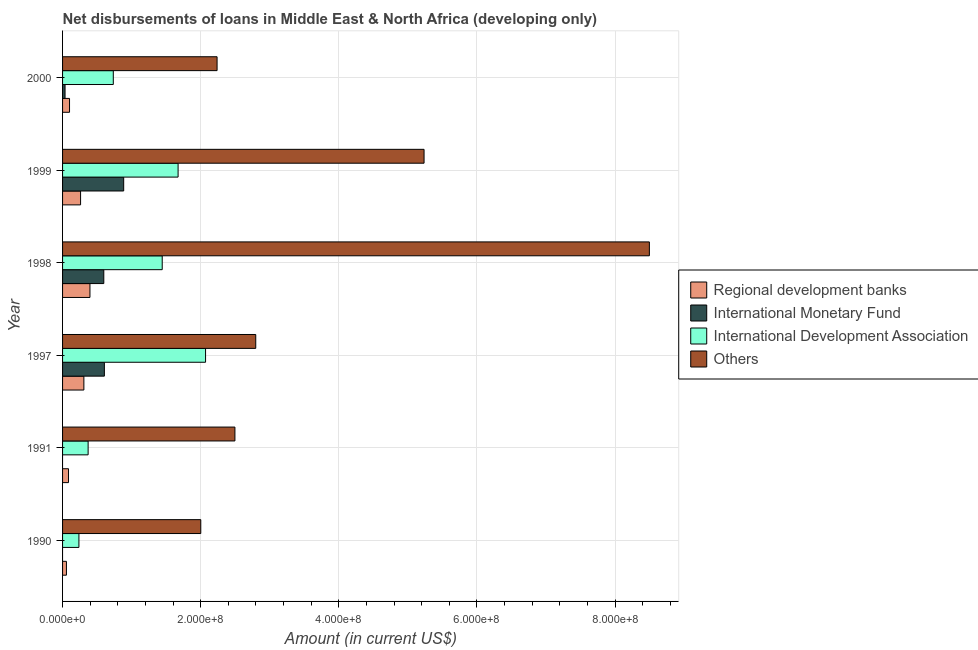How many groups of bars are there?
Give a very brief answer. 6. What is the amount of loan disimbursed by international development association in 1990?
Keep it short and to the point. 2.37e+07. Across all years, what is the maximum amount of loan disimbursed by regional development banks?
Offer a terse response. 3.97e+07. Across all years, what is the minimum amount of loan disimbursed by international monetary fund?
Your response must be concise. 0. What is the total amount of loan disimbursed by international development association in the graph?
Provide a short and direct response. 6.53e+08. What is the difference between the amount of loan disimbursed by international monetary fund in 1998 and that in 2000?
Your answer should be compact. 5.61e+07. What is the difference between the amount of loan disimbursed by regional development banks in 2000 and the amount of loan disimbursed by international development association in 1991?
Give a very brief answer. -2.69e+07. What is the average amount of loan disimbursed by regional development banks per year?
Offer a terse response. 2.01e+07. In the year 1990, what is the difference between the amount of loan disimbursed by international development association and amount of loan disimbursed by regional development banks?
Your answer should be very brief. 1.81e+07. Is the amount of loan disimbursed by international monetary fund in 1999 less than that in 2000?
Ensure brevity in your answer.  No. What is the difference between the highest and the second highest amount of loan disimbursed by international development association?
Your answer should be very brief. 3.98e+07. What is the difference between the highest and the lowest amount of loan disimbursed by regional development banks?
Your answer should be very brief. 3.40e+07. Is it the case that in every year, the sum of the amount of loan disimbursed by international monetary fund and amount of loan disimbursed by international development association is greater than the sum of amount of loan disimbursed by other organisations and amount of loan disimbursed by regional development banks?
Your answer should be compact. No. How many bars are there?
Your answer should be very brief. 22. Are all the bars in the graph horizontal?
Your answer should be compact. Yes. How many years are there in the graph?
Your response must be concise. 6. Does the graph contain any zero values?
Offer a very short reply. Yes. What is the title of the graph?
Your response must be concise. Net disbursements of loans in Middle East & North Africa (developing only). Does "Luxembourg" appear as one of the legend labels in the graph?
Your response must be concise. No. What is the label or title of the Y-axis?
Offer a very short reply. Year. What is the Amount (in current US$) in Regional development banks in 1990?
Keep it short and to the point. 5.62e+06. What is the Amount (in current US$) in International Development Association in 1990?
Give a very brief answer. 2.37e+07. What is the Amount (in current US$) in Others in 1990?
Ensure brevity in your answer.  2.00e+08. What is the Amount (in current US$) in Regional development banks in 1991?
Provide a succinct answer. 8.61e+06. What is the Amount (in current US$) of International Development Association in 1991?
Your response must be concise. 3.70e+07. What is the Amount (in current US$) in Others in 1991?
Keep it short and to the point. 2.50e+08. What is the Amount (in current US$) of Regional development banks in 1997?
Give a very brief answer. 3.09e+07. What is the Amount (in current US$) of International Monetary Fund in 1997?
Offer a very short reply. 6.05e+07. What is the Amount (in current US$) of International Development Association in 1997?
Make the answer very short. 2.07e+08. What is the Amount (in current US$) in Others in 1997?
Ensure brevity in your answer.  2.80e+08. What is the Amount (in current US$) in Regional development banks in 1998?
Make the answer very short. 3.97e+07. What is the Amount (in current US$) of International Monetary Fund in 1998?
Provide a short and direct response. 5.97e+07. What is the Amount (in current US$) of International Development Association in 1998?
Make the answer very short. 1.44e+08. What is the Amount (in current US$) of Others in 1998?
Ensure brevity in your answer.  8.50e+08. What is the Amount (in current US$) of Regional development banks in 1999?
Keep it short and to the point. 2.61e+07. What is the Amount (in current US$) of International Monetary Fund in 1999?
Your response must be concise. 8.85e+07. What is the Amount (in current US$) of International Development Association in 1999?
Provide a short and direct response. 1.67e+08. What is the Amount (in current US$) of Others in 1999?
Provide a short and direct response. 5.23e+08. What is the Amount (in current US$) of Regional development banks in 2000?
Offer a terse response. 1.01e+07. What is the Amount (in current US$) in International Monetary Fund in 2000?
Offer a terse response. 3.60e+06. What is the Amount (in current US$) in International Development Association in 2000?
Your answer should be compact. 7.35e+07. What is the Amount (in current US$) in Others in 2000?
Offer a terse response. 2.24e+08. Across all years, what is the maximum Amount (in current US$) in Regional development banks?
Keep it short and to the point. 3.97e+07. Across all years, what is the maximum Amount (in current US$) of International Monetary Fund?
Provide a short and direct response. 8.85e+07. Across all years, what is the maximum Amount (in current US$) in International Development Association?
Provide a short and direct response. 2.07e+08. Across all years, what is the maximum Amount (in current US$) in Others?
Offer a terse response. 8.50e+08. Across all years, what is the minimum Amount (in current US$) in Regional development banks?
Ensure brevity in your answer.  5.62e+06. Across all years, what is the minimum Amount (in current US$) in International Monetary Fund?
Offer a terse response. 0. Across all years, what is the minimum Amount (in current US$) of International Development Association?
Offer a very short reply. 2.37e+07. Across all years, what is the minimum Amount (in current US$) of Others?
Keep it short and to the point. 2.00e+08. What is the total Amount (in current US$) in Regional development banks in the graph?
Provide a short and direct response. 1.21e+08. What is the total Amount (in current US$) of International Monetary Fund in the graph?
Your answer should be compact. 2.12e+08. What is the total Amount (in current US$) in International Development Association in the graph?
Your response must be concise. 6.53e+08. What is the total Amount (in current US$) of Others in the graph?
Your response must be concise. 2.33e+09. What is the difference between the Amount (in current US$) in Regional development banks in 1990 and that in 1991?
Offer a very short reply. -2.99e+06. What is the difference between the Amount (in current US$) in International Development Association in 1990 and that in 1991?
Provide a short and direct response. -1.33e+07. What is the difference between the Amount (in current US$) in Others in 1990 and that in 1991?
Your response must be concise. -4.94e+07. What is the difference between the Amount (in current US$) in Regional development banks in 1990 and that in 1997?
Your answer should be compact. -2.52e+07. What is the difference between the Amount (in current US$) in International Development Association in 1990 and that in 1997?
Offer a very short reply. -1.83e+08. What is the difference between the Amount (in current US$) in Others in 1990 and that in 1997?
Keep it short and to the point. -7.96e+07. What is the difference between the Amount (in current US$) of Regional development banks in 1990 and that in 1998?
Ensure brevity in your answer.  -3.40e+07. What is the difference between the Amount (in current US$) of International Development Association in 1990 and that in 1998?
Your response must be concise. -1.21e+08. What is the difference between the Amount (in current US$) in Others in 1990 and that in 1998?
Keep it short and to the point. -6.50e+08. What is the difference between the Amount (in current US$) in Regional development banks in 1990 and that in 1999?
Give a very brief answer. -2.05e+07. What is the difference between the Amount (in current US$) in International Development Association in 1990 and that in 1999?
Give a very brief answer. -1.44e+08. What is the difference between the Amount (in current US$) of Others in 1990 and that in 1999?
Give a very brief answer. -3.23e+08. What is the difference between the Amount (in current US$) of Regional development banks in 1990 and that in 2000?
Your answer should be very brief. -4.46e+06. What is the difference between the Amount (in current US$) in International Development Association in 1990 and that in 2000?
Provide a short and direct response. -4.98e+07. What is the difference between the Amount (in current US$) in Others in 1990 and that in 2000?
Your answer should be compact. -2.36e+07. What is the difference between the Amount (in current US$) of Regional development banks in 1991 and that in 1997?
Make the answer very short. -2.22e+07. What is the difference between the Amount (in current US$) of International Development Association in 1991 and that in 1997?
Provide a succinct answer. -1.70e+08. What is the difference between the Amount (in current US$) of Others in 1991 and that in 1997?
Keep it short and to the point. -3.02e+07. What is the difference between the Amount (in current US$) in Regional development banks in 1991 and that in 1998?
Your answer should be compact. -3.10e+07. What is the difference between the Amount (in current US$) of International Development Association in 1991 and that in 1998?
Your response must be concise. -1.07e+08. What is the difference between the Amount (in current US$) of Others in 1991 and that in 1998?
Keep it short and to the point. -6.00e+08. What is the difference between the Amount (in current US$) of Regional development banks in 1991 and that in 1999?
Your answer should be very brief. -1.75e+07. What is the difference between the Amount (in current US$) in International Development Association in 1991 and that in 1999?
Provide a short and direct response. -1.30e+08. What is the difference between the Amount (in current US$) of Others in 1991 and that in 1999?
Provide a short and direct response. -2.74e+08. What is the difference between the Amount (in current US$) in Regional development banks in 1991 and that in 2000?
Give a very brief answer. -1.47e+06. What is the difference between the Amount (in current US$) in International Development Association in 1991 and that in 2000?
Make the answer very short. -3.65e+07. What is the difference between the Amount (in current US$) in Others in 1991 and that in 2000?
Offer a very short reply. 2.58e+07. What is the difference between the Amount (in current US$) in Regional development banks in 1997 and that in 1998?
Your answer should be compact. -8.80e+06. What is the difference between the Amount (in current US$) in International Monetary Fund in 1997 and that in 1998?
Your response must be concise. 8.50e+05. What is the difference between the Amount (in current US$) of International Development Association in 1997 and that in 1998?
Your response must be concise. 6.28e+07. What is the difference between the Amount (in current US$) of Others in 1997 and that in 1998?
Your answer should be very brief. -5.70e+08. What is the difference between the Amount (in current US$) in Regional development banks in 1997 and that in 1999?
Provide a short and direct response. 4.76e+06. What is the difference between the Amount (in current US$) of International Monetary Fund in 1997 and that in 1999?
Ensure brevity in your answer.  -2.80e+07. What is the difference between the Amount (in current US$) of International Development Association in 1997 and that in 1999?
Ensure brevity in your answer.  3.98e+07. What is the difference between the Amount (in current US$) of Others in 1997 and that in 1999?
Ensure brevity in your answer.  -2.44e+08. What is the difference between the Amount (in current US$) in Regional development banks in 1997 and that in 2000?
Offer a terse response. 2.08e+07. What is the difference between the Amount (in current US$) of International Monetary Fund in 1997 and that in 2000?
Offer a very short reply. 5.70e+07. What is the difference between the Amount (in current US$) of International Development Association in 1997 and that in 2000?
Ensure brevity in your answer.  1.34e+08. What is the difference between the Amount (in current US$) in Others in 1997 and that in 2000?
Keep it short and to the point. 5.60e+07. What is the difference between the Amount (in current US$) of Regional development banks in 1998 and that in 1999?
Offer a very short reply. 1.36e+07. What is the difference between the Amount (in current US$) in International Monetary Fund in 1998 and that in 1999?
Your response must be concise. -2.88e+07. What is the difference between the Amount (in current US$) in International Development Association in 1998 and that in 1999?
Provide a short and direct response. -2.30e+07. What is the difference between the Amount (in current US$) in Others in 1998 and that in 1999?
Offer a very short reply. 3.26e+08. What is the difference between the Amount (in current US$) of Regional development banks in 1998 and that in 2000?
Provide a short and direct response. 2.96e+07. What is the difference between the Amount (in current US$) in International Monetary Fund in 1998 and that in 2000?
Provide a short and direct response. 5.61e+07. What is the difference between the Amount (in current US$) in International Development Association in 1998 and that in 2000?
Keep it short and to the point. 7.08e+07. What is the difference between the Amount (in current US$) of Others in 1998 and that in 2000?
Keep it short and to the point. 6.26e+08. What is the difference between the Amount (in current US$) in Regional development banks in 1999 and that in 2000?
Make the answer very short. 1.60e+07. What is the difference between the Amount (in current US$) in International Monetary Fund in 1999 and that in 2000?
Your answer should be very brief. 8.49e+07. What is the difference between the Amount (in current US$) of International Development Association in 1999 and that in 2000?
Make the answer very short. 9.38e+07. What is the difference between the Amount (in current US$) of Others in 1999 and that in 2000?
Ensure brevity in your answer.  3.00e+08. What is the difference between the Amount (in current US$) of Regional development banks in 1990 and the Amount (in current US$) of International Development Association in 1991?
Ensure brevity in your answer.  -3.14e+07. What is the difference between the Amount (in current US$) of Regional development banks in 1990 and the Amount (in current US$) of Others in 1991?
Give a very brief answer. -2.44e+08. What is the difference between the Amount (in current US$) in International Development Association in 1990 and the Amount (in current US$) in Others in 1991?
Offer a very short reply. -2.26e+08. What is the difference between the Amount (in current US$) in Regional development banks in 1990 and the Amount (in current US$) in International Monetary Fund in 1997?
Your answer should be very brief. -5.49e+07. What is the difference between the Amount (in current US$) in Regional development banks in 1990 and the Amount (in current US$) in International Development Association in 1997?
Your response must be concise. -2.01e+08. What is the difference between the Amount (in current US$) of Regional development banks in 1990 and the Amount (in current US$) of Others in 1997?
Your response must be concise. -2.74e+08. What is the difference between the Amount (in current US$) of International Development Association in 1990 and the Amount (in current US$) of Others in 1997?
Give a very brief answer. -2.56e+08. What is the difference between the Amount (in current US$) of Regional development banks in 1990 and the Amount (in current US$) of International Monetary Fund in 1998?
Provide a short and direct response. -5.41e+07. What is the difference between the Amount (in current US$) in Regional development banks in 1990 and the Amount (in current US$) in International Development Association in 1998?
Ensure brevity in your answer.  -1.39e+08. What is the difference between the Amount (in current US$) in Regional development banks in 1990 and the Amount (in current US$) in Others in 1998?
Offer a very short reply. -8.44e+08. What is the difference between the Amount (in current US$) of International Development Association in 1990 and the Amount (in current US$) of Others in 1998?
Make the answer very short. -8.26e+08. What is the difference between the Amount (in current US$) in Regional development banks in 1990 and the Amount (in current US$) in International Monetary Fund in 1999?
Your answer should be compact. -8.29e+07. What is the difference between the Amount (in current US$) of Regional development banks in 1990 and the Amount (in current US$) of International Development Association in 1999?
Your answer should be compact. -1.62e+08. What is the difference between the Amount (in current US$) of Regional development banks in 1990 and the Amount (in current US$) of Others in 1999?
Your answer should be compact. -5.18e+08. What is the difference between the Amount (in current US$) in International Development Association in 1990 and the Amount (in current US$) in Others in 1999?
Give a very brief answer. -5.00e+08. What is the difference between the Amount (in current US$) in Regional development banks in 1990 and the Amount (in current US$) in International Monetary Fund in 2000?
Offer a terse response. 2.02e+06. What is the difference between the Amount (in current US$) of Regional development banks in 1990 and the Amount (in current US$) of International Development Association in 2000?
Offer a very short reply. -6.79e+07. What is the difference between the Amount (in current US$) in Regional development banks in 1990 and the Amount (in current US$) in Others in 2000?
Offer a terse response. -2.18e+08. What is the difference between the Amount (in current US$) in International Development Association in 1990 and the Amount (in current US$) in Others in 2000?
Your answer should be very brief. -2.00e+08. What is the difference between the Amount (in current US$) in Regional development banks in 1991 and the Amount (in current US$) in International Monetary Fund in 1997?
Offer a terse response. -5.19e+07. What is the difference between the Amount (in current US$) of Regional development banks in 1991 and the Amount (in current US$) of International Development Association in 1997?
Your answer should be very brief. -1.98e+08. What is the difference between the Amount (in current US$) of Regional development banks in 1991 and the Amount (in current US$) of Others in 1997?
Ensure brevity in your answer.  -2.71e+08. What is the difference between the Amount (in current US$) in International Development Association in 1991 and the Amount (in current US$) in Others in 1997?
Ensure brevity in your answer.  -2.43e+08. What is the difference between the Amount (in current US$) in Regional development banks in 1991 and the Amount (in current US$) in International Monetary Fund in 1998?
Keep it short and to the point. -5.11e+07. What is the difference between the Amount (in current US$) in Regional development banks in 1991 and the Amount (in current US$) in International Development Association in 1998?
Ensure brevity in your answer.  -1.36e+08. What is the difference between the Amount (in current US$) in Regional development banks in 1991 and the Amount (in current US$) in Others in 1998?
Your response must be concise. -8.41e+08. What is the difference between the Amount (in current US$) of International Development Association in 1991 and the Amount (in current US$) of Others in 1998?
Offer a very short reply. -8.13e+08. What is the difference between the Amount (in current US$) of Regional development banks in 1991 and the Amount (in current US$) of International Monetary Fund in 1999?
Keep it short and to the point. -7.99e+07. What is the difference between the Amount (in current US$) of Regional development banks in 1991 and the Amount (in current US$) of International Development Association in 1999?
Ensure brevity in your answer.  -1.59e+08. What is the difference between the Amount (in current US$) in Regional development banks in 1991 and the Amount (in current US$) in Others in 1999?
Your answer should be very brief. -5.15e+08. What is the difference between the Amount (in current US$) in International Development Association in 1991 and the Amount (in current US$) in Others in 1999?
Keep it short and to the point. -4.86e+08. What is the difference between the Amount (in current US$) in Regional development banks in 1991 and the Amount (in current US$) in International Monetary Fund in 2000?
Your answer should be compact. 5.01e+06. What is the difference between the Amount (in current US$) of Regional development banks in 1991 and the Amount (in current US$) of International Development Association in 2000?
Keep it short and to the point. -6.49e+07. What is the difference between the Amount (in current US$) in Regional development banks in 1991 and the Amount (in current US$) in Others in 2000?
Your answer should be compact. -2.15e+08. What is the difference between the Amount (in current US$) of International Development Association in 1991 and the Amount (in current US$) of Others in 2000?
Make the answer very short. -1.87e+08. What is the difference between the Amount (in current US$) of Regional development banks in 1997 and the Amount (in current US$) of International Monetary Fund in 1998?
Offer a terse response. -2.88e+07. What is the difference between the Amount (in current US$) in Regional development banks in 1997 and the Amount (in current US$) in International Development Association in 1998?
Your answer should be compact. -1.13e+08. What is the difference between the Amount (in current US$) of Regional development banks in 1997 and the Amount (in current US$) of Others in 1998?
Offer a terse response. -8.19e+08. What is the difference between the Amount (in current US$) of International Monetary Fund in 1997 and the Amount (in current US$) of International Development Association in 1998?
Give a very brief answer. -8.37e+07. What is the difference between the Amount (in current US$) in International Monetary Fund in 1997 and the Amount (in current US$) in Others in 1998?
Provide a short and direct response. -7.89e+08. What is the difference between the Amount (in current US$) of International Development Association in 1997 and the Amount (in current US$) of Others in 1998?
Provide a short and direct response. -6.43e+08. What is the difference between the Amount (in current US$) in Regional development banks in 1997 and the Amount (in current US$) in International Monetary Fund in 1999?
Offer a terse response. -5.77e+07. What is the difference between the Amount (in current US$) in Regional development banks in 1997 and the Amount (in current US$) in International Development Association in 1999?
Give a very brief answer. -1.36e+08. What is the difference between the Amount (in current US$) in Regional development banks in 1997 and the Amount (in current US$) in Others in 1999?
Offer a terse response. -4.93e+08. What is the difference between the Amount (in current US$) in International Monetary Fund in 1997 and the Amount (in current US$) in International Development Association in 1999?
Your answer should be very brief. -1.07e+08. What is the difference between the Amount (in current US$) in International Monetary Fund in 1997 and the Amount (in current US$) in Others in 1999?
Give a very brief answer. -4.63e+08. What is the difference between the Amount (in current US$) in International Development Association in 1997 and the Amount (in current US$) in Others in 1999?
Keep it short and to the point. -3.16e+08. What is the difference between the Amount (in current US$) of Regional development banks in 1997 and the Amount (in current US$) of International Monetary Fund in 2000?
Your answer should be compact. 2.73e+07. What is the difference between the Amount (in current US$) of Regional development banks in 1997 and the Amount (in current US$) of International Development Association in 2000?
Your response must be concise. -4.26e+07. What is the difference between the Amount (in current US$) of Regional development banks in 1997 and the Amount (in current US$) of Others in 2000?
Give a very brief answer. -1.93e+08. What is the difference between the Amount (in current US$) of International Monetary Fund in 1997 and the Amount (in current US$) of International Development Association in 2000?
Provide a succinct answer. -1.29e+07. What is the difference between the Amount (in current US$) of International Monetary Fund in 1997 and the Amount (in current US$) of Others in 2000?
Ensure brevity in your answer.  -1.63e+08. What is the difference between the Amount (in current US$) of International Development Association in 1997 and the Amount (in current US$) of Others in 2000?
Your response must be concise. -1.67e+07. What is the difference between the Amount (in current US$) in Regional development banks in 1998 and the Amount (in current US$) in International Monetary Fund in 1999?
Make the answer very short. -4.89e+07. What is the difference between the Amount (in current US$) in Regional development banks in 1998 and the Amount (in current US$) in International Development Association in 1999?
Your answer should be very brief. -1.28e+08. What is the difference between the Amount (in current US$) in Regional development banks in 1998 and the Amount (in current US$) in Others in 1999?
Your answer should be compact. -4.84e+08. What is the difference between the Amount (in current US$) in International Monetary Fund in 1998 and the Amount (in current US$) in International Development Association in 1999?
Provide a short and direct response. -1.08e+08. What is the difference between the Amount (in current US$) of International Monetary Fund in 1998 and the Amount (in current US$) of Others in 1999?
Offer a very short reply. -4.64e+08. What is the difference between the Amount (in current US$) in International Development Association in 1998 and the Amount (in current US$) in Others in 1999?
Provide a succinct answer. -3.79e+08. What is the difference between the Amount (in current US$) in Regional development banks in 1998 and the Amount (in current US$) in International Monetary Fund in 2000?
Make the answer very short. 3.61e+07. What is the difference between the Amount (in current US$) of Regional development banks in 1998 and the Amount (in current US$) of International Development Association in 2000?
Offer a very short reply. -3.38e+07. What is the difference between the Amount (in current US$) in Regional development banks in 1998 and the Amount (in current US$) in Others in 2000?
Provide a short and direct response. -1.84e+08. What is the difference between the Amount (in current US$) in International Monetary Fund in 1998 and the Amount (in current US$) in International Development Association in 2000?
Your answer should be very brief. -1.38e+07. What is the difference between the Amount (in current US$) of International Monetary Fund in 1998 and the Amount (in current US$) of Others in 2000?
Offer a terse response. -1.64e+08. What is the difference between the Amount (in current US$) in International Development Association in 1998 and the Amount (in current US$) in Others in 2000?
Your answer should be very brief. -7.94e+07. What is the difference between the Amount (in current US$) in Regional development banks in 1999 and the Amount (in current US$) in International Monetary Fund in 2000?
Your response must be concise. 2.25e+07. What is the difference between the Amount (in current US$) in Regional development banks in 1999 and the Amount (in current US$) in International Development Association in 2000?
Your answer should be very brief. -4.74e+07. What is the difference between the Amount (in current US$) in Regional development banks in 1999 and the Amount (in current US$) in Others in 2000?
Give a very brief answer. -1.98e+08. What is the difference between the Amount (in current US$) in International Monetary Fund in 1999 and the Amount (in current US$) in International Development Association in 2000?
Provide a short and direct response. 1.50e+07. What is the difference between the Amount (in current US$) of International Monetary Fund in 1999 and the Amount (in current US$) of Others in 2000?
Ensure brevity in your answer.  -1.35e+08. What is the difference between the Amount (in current US$) in International Development Association in 1999 and the Amount (in current US$) in Others in 2000?
Ensure brevity in your answer.  -5.65e+07. What is the average Amount (in current US$) in Regional development banks per year?
Offer a terse response. 2.01e+07. What is the average Amount (in current US$) of International Monetary Fund per year?
Ensure brevity in your answer.  3.54e+07. What is the average Amount (in current US$) in International Development Association per year?
Make the answer very short. 1.09e+08. What is the average Amount (in current US$) of Others per year?
Your answer should be very brief. 3.88e+08. In the year 1990, what is the difference between the Amount (in current US$) of Regional development banks and Amount (in current US$) of International Development Association?
Your response must be concise. -1.81e+07. In the year 1990, what is the difference between the Amount (in current US$) of Regional development banks and Amount (in current US$) of Others?
Your response must be concise. -1.95e+08. In the year 1990, what is the difference between the Amount (in current US$) of International Development Association and Amount (in current US$) of Others?
Make the answer very short. -1.76e+08. In the year 1991, what is the difference between the Amount (in current US$) of Regional development banks and Amount (in current US$) of International Development Association?
Give a very brief answer. -2.84e+07. In the year 1991, what is the difference between the Amount (in current US$) in Regional development banks and Amount (in current US$) in Others?
Provide a short and direct response. -2.41e+08. In the year 1991, what is the difference between the Amount (in current US$) of International Development Association and Amount (in current US$) of Others?
Your response must be concise. -2.13e+08. In the year 1997, what is the difference between the Amount (in current US$) of Regional development banks and Amount (in current US$) of International Monetary Fund?
Your response must be concise. -2.97e+07. In the year 1997, what is the difference between the Amount (in current US$) of Regional development banks and Amount (in current US$) of International Development Association?
Ensure brevity in your answer.  -1.76e+08. In the year 1997, what is the difference between the Amount (in current US$) of Regional development banks and Amount (in current US$) of Others?
Your answer should be compact. -2.49e+08. In the year 1997, what is the difference between the Amount (in current US$) in International Monetary Fund and Amount (in current US$) in International Development Association?
Provide a short and direct response. -1.47e+08. In the year 1997, what is the difference between the Amount (in current US$) in International Monetary Fund and Amount (in current US$) in Others?
Offer a very short reply. -2.19e+08. In the year 1997, what is the difference between the Amount (in current US$) of International Development Association and Amount (in current US$) of Others?
Offer a terse response. -7.27e+07. In the year 1998, what is the difference between the Amount (in current US$) of Regional development banks and Amount (in current US$) of International Monetary Fund?
Your answer should be compact. -2.00e+07. In the year 1998, what is the difference between the Amount (in current US$) in Regional development banks and Amount (in current US$) in International Development Association?
Ensure brevity in your answer.  -1.05e+08. In the year 1998, what is the difference between the Amount (in current US$) of Regional development banks and Amount (in current US$) of Others?
Provide a short and direct response. -8.10e+08. In the year 1998, what is the difference between the Amount (in current US$) in International Monetary Fund and Amount (in current US$) in International Development Association?
Your answer should be compact. -8.46e+07. In the year 1998, what is the difference between the Amount (in current US$) in International Monetary Fund and Amount (in current US$) in Others?
Give a very brief answer. -7.90e+08. In the year 1998, what is the difference between the Amount (in current US$) in International Development Association and Amount (in current US$) in Others?
Give a very brief answer. -7.05e+08. In the year 1999, what is the difference between the Amount (in current US$) in Regional development banks and Amount (in current US$) in International Monetary Fund?
Your response must be concise. -6.24e+07. In the year 1999, what is the difference between the Amount (in current US$) of Regional development banks and Amount (in current US$) of International Development Association?
Your response must be concise. -1.41e+08. In the year 1999, what is the difference between the Amount (in current US$) of Regional development banks and Amount (in current US$) of Others?
Keep it short and to the point. -4.97e+08. In the year 1999, what is the difference between the Amount (in current US$) of International Monetary Fund and Amount (in current US$) of International Development Association?
Offer a terse response. -7.88e+07. In the year 1999, what is the difference between the Amount (in current US$) of International Monetary Fund and Amount (in current US$) of Others?
Provide a succinct answer. -4.35e+08. In the year 1999, what is the difference between the Amount (in current US$) in International Development Association and Amount (in current US$) in Others?
Offer a very short reply. -3.56e+08. In the year 2000, what is the difference between the Amount (in current US$) in Regional development banks and Amount (in current US$) in International Monetary Fund?
Offer a very short reply. 6.48e+06. In the year 2000, what is the difference between the Amount (in current US$) in Regional development banks and Amount (in current US$) in International Development Association?
Provide a succinct answer. -6.34e+07. In the year 2000, what is the difference between the Amount (in current US$) in Regional development banks and Amount (in current US$) in Others?
Provide a succinct answer. -2.14e+08. In the year 2000, what is the difference between the Amount (in current US$) of International Monetary Fund and Amount (in current US$) of International Development Association?
Ensure brevity in your answer.  -6.99e+07. In the year 2000, what is the difference between the Amount (in current US$) of International Monetary Fund and Amount (in current US$) of Others?
Your response must be concise. -2.20e+08. In the year 2000, what is the difference between the Amount (in current US$) of International Development Association and Amount (in current US$) of Others?
Offer a very short reply. -1.50e+08. What is the ratio of the Amount (in current US$) in Regional development banks in 1990 to that in 1991?
Your response must be concise. 0.65. What is the ratio of the Amount (in current US$) in International Development Association in 1990 to that in 1991?
Provide a short and direct response. 0.64. What is the ratio of the Amount (in current US$) of Others in 1990 to that in 1991?
Give a very brief answer. 0.8. What is the ratio of the Amount (in current US$) of Regional development banks in 1990 to that in 1997?
Provide a succinct answer. 0.18. What is the ratio of the Amount (in current US$) of International Development Association in 1990 to that in 1997?
Make the answer very short. 0.11. What is the ratio of the Amount (in current US$) in Others in 1990 to that in 1997?
Make the answer very short. 0.72. What is the ratio of the Amount (in current US$) in Regional development banks in 1990 to that in 1998?
Offer a very short reply. 0.14. What is the ratio of the Amount (in current US$) in International Development Association in 1990 to that in 1998?
Ensure brevity in your answer.  0.16. What is the ratio of the Amount (in current US$) in Others in 1990 to that in 1998?
Provide a succinct answer. 0.24. What is the ratio of the Amount (in current US$) in Regional development banks in 1990 to that in 1999?
Your response must be concise. 0.22. What is the ratio of the Amount (in current US$) of International Development Association in 1990 to that in 1999?
Your answer should be very brief. 0.14. What is the ratio of the Amount (in current US$) in Others in 1990 to that in 1999?
Offer a terse response. 0.38. What is the ratio of the Amount (in current US$) in Regional development banks in 1990 to that in 2000?
Give a very brief answer. 0.56. What is the ratio of the Amount (in current US$) of International Development Association in 1990 to that in 2000?
Your answer should be compact. 0.32. What is the ratio of the Amount (in current US$) of Others in 1990 to that in 2000?
Offer a very short reply. 0.89. What is the ratio of the Amount (in current US$) of Regional development banks in 1991 to that in 1997?
Give a very brief answer. 0.28. What is the ratio of the Amount (in current US$) in International Development Association in 1991 to that in 1997?
Your answer should be very brief. 0.18. What is the ratio of the Amount (in current US$) of Others in 1991 to that in 1997?
Offer a very short reply. 0.89. What is the ratio of the Amount (in current US$) in Regional development banks in 1991 to that in 1998?
Keep it short and to the point. 0.22. What is the ratio of the Amount (in current US$) in International Development Association in 1991 to that in 1998?
Provide a succinct answer. 0.26. What is the ratio of the Amount (in current US$) of Others in 1991 to that in 1998?
Give a very brief answer. 0.29. What is the ratio of the Amount (in current US$) in Regional development banks in 1991 to that in 1999?
Make the answer very short. 0.33. What is the ratio of the Amount (in current US$) of International Development Association in 1991 to that in 1999?
Offer a very short reply. 0.22. What is the ratio of the Amount (in current US$) in Others in 1991 to that in 1999?
Provide a short and direct response. 0.48. What is the ratio of the Amount (in current US$) in Regional development banks in 1991 to that in 2000?
Your answer should be very brief. 0.85. What is the ratio of the Amount (in current US$) of International Development Association in 1991 to that in 2000?
Offer a very short reply. 0.5. What is the ratio of the Amount (in current US$) of Others in 1991 to that in 2000?
Provide a short and direct response. 1.12. What is the ratio of the Amount (in current US$) in Regional development banks in 1997 to that in 1998?
Offer a terse response. 0.78. What is the ratio of the Amount (in current US$) of International Monetary Fund in 1997 to that in 1998?
Offer a very short reply. 1.01. What is the ratio of the Amount (in current US$) of International Development Association in 1997 to that in 1998?
Provide a short and direct response. 1.43. What is the ratio of the Amount (in current US$) of Others in 1997 to that in 1998?
Provide a succinct answer. 0.33. What is the ratio of the Amount (in current US$) of Regional development banks in 1997 to that in 1999?
Give a very brief answer. 1.18. What is the ratio of the Amount (in current US$) in International Monetary Fund in 1997 to that in 1999?
Your answer should be compact. 0.68. What is the ratio of the Amount (in current US$) of International Development Association in 1997 to that in 1999?
Your response must be concise. 1.24. What is the ratio of the Amount (in current US$) of Others in 1997 to that in 1999?
Ensure brevity in your answer.  0.53. What is the ratio of the Amount (in current US$) in Regional development banks in 1997 to that in 2000?
Make the answer very short. 3.06. What is the ratio of the Amount (in current US$) of International Monetary Fund in 1997 to that in 2000?
Ensure brevity in your answer.  16.84. What is the ratio of the Amount (in current US$) of International Development Association in 1997 to that in 2000?
Your answer should be very brief. 2.82. What is the ratio of the Amount (in current US$) in Others in 1997 to that in 2000?
Keep it short and to the point. 1.25. What is the ratio of the Amount (in current US$) of Regional development banks in 1998 to that in 1999?
Keep it short and to the point. 1.52. What is the ratio of the Amount (in current US$) in International Monetary Fund in 1998 to that in 1999?
Ensure brevity in your answer.  0.67. What is the ratio of the Amount (in current US$) of International Development Association in 1998 to that in 1999?
Ensure brevity in your answer.  0.86. What is the ratio of the Amount (in current US$) of Others in 1998 to that in 1999?
Your answer should be compact. 1.62. What is the ratio of the Amount (in current US$) in Regional development banks in 1998 to that in 2000?
Your response must be concise. 3.93. What is the ratio of the Amount (in current US$) in International Monetary Fund in 1998 to that in 2000?
Keep it short and to the point. 16.6. What is the ratio of the Amount (in current US$) of International Development Association in 1998 to that in 2000?
Give a very brief answer. 1.96. What is the ratio of the Amount (in current US$) of Others in 1998 to that in 2000?
Offer a very short reply. 3.8. What is the ratio of the Amount (in current US$) of Regional development banks in 1999 to that in 2000?
Your answer should be very brief. 2.59. What is the ratio of the Amount (in current US$) of International Monetary Fund in 1999 to that in 2000?
Keep it short and to the point. 24.61. What is the ratio of the Amount (in current US$) of International Development Association in 1999 to that in 2000?
Offer a terse response. 2.28. What is the ratio of the Amount (in current US$) of Others in 1999 to that in 2000?
Keep it short and to the point. 2.34. What is the difference between the highest and the second highest Amount (in current US$) of Regional development banks?
Make the answer very short. 8.80e+06. What is the difference between the highest and the second highest Amount (in current US$) of International Monetary Fund?
Give a very brief answer. 2.80e+07. What is the difference between the highest and the second highest Amount (in current US$) of International Development Association?
Keep it short and to the point. 3.98e+07. What is the difference between the highest and the second highest Amount (in current US$) of Others?
Your answer should be compact. 3.26e+08. What is the difference between the highest and the lowest Amount (in current US$) in Regional development banks?
Provide a short and direct response. 3.40e+07. What is the difference between the highest and the lowest Amount (in current US$) in International Monetary Fund?
Offer a terse response. 8.85e+07. What is the difference between the highest and the lowest Amount (in current US$) in International Development Association?
Provide a short and direct response. 1.83e+08. What is the difference between the highest and the lowest Amount (in current US$) in Others?
Offer a very short reply. 6.50e+08. 